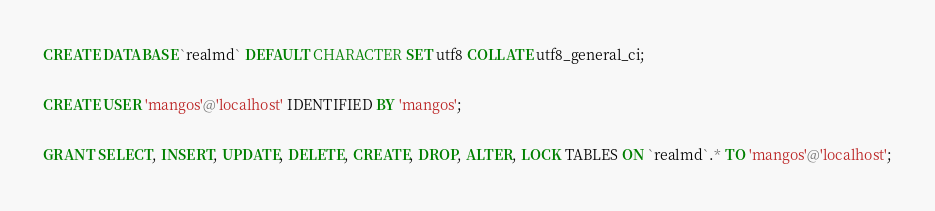<code> <loc_0><loc_0><loc_500><loc_500><_SQL_>CREATE DATABASE `realmd` DEFAULT CHARACTER SET utf8 COLLATE utf8_general_ci;

CREATE USER 'mangos'@'localhost' IDENTIFIED BY 'mangos';

GRANT SELECT, INSERT, UPDATE, DELETE, CREATE, DROP, ALTER, LOCK TABLES ON `realmd`.* TO 'mangos'@'localhost';
</code> 